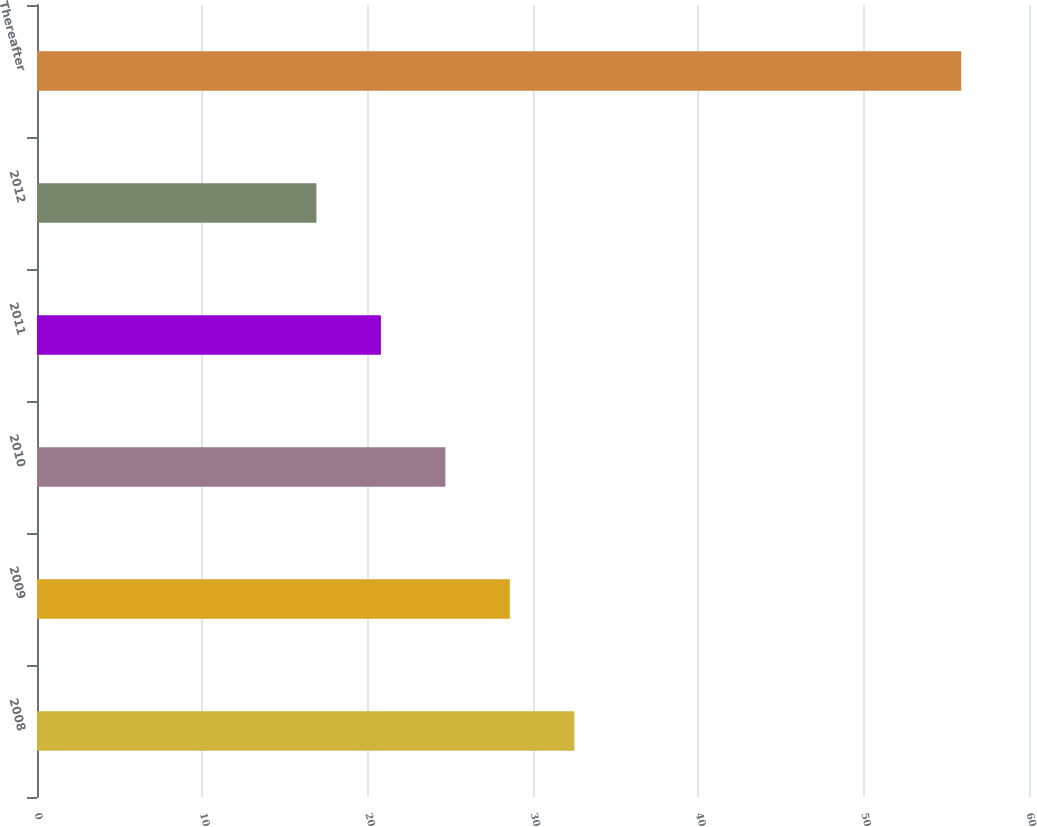Convert chart to OTSL. <chart><loc_0><loc_0><loc_500><loc_500><bar_chart><fcel>2008<fcel>2009<fcel>2010<fcel>2011<fcel>2012<fcel>Thereafter<nl><fcel>32.5<fcel>28.6<fcel>24.7<fcel>20.8<fcel>16.9<fcel>55.9<nl></chart> 